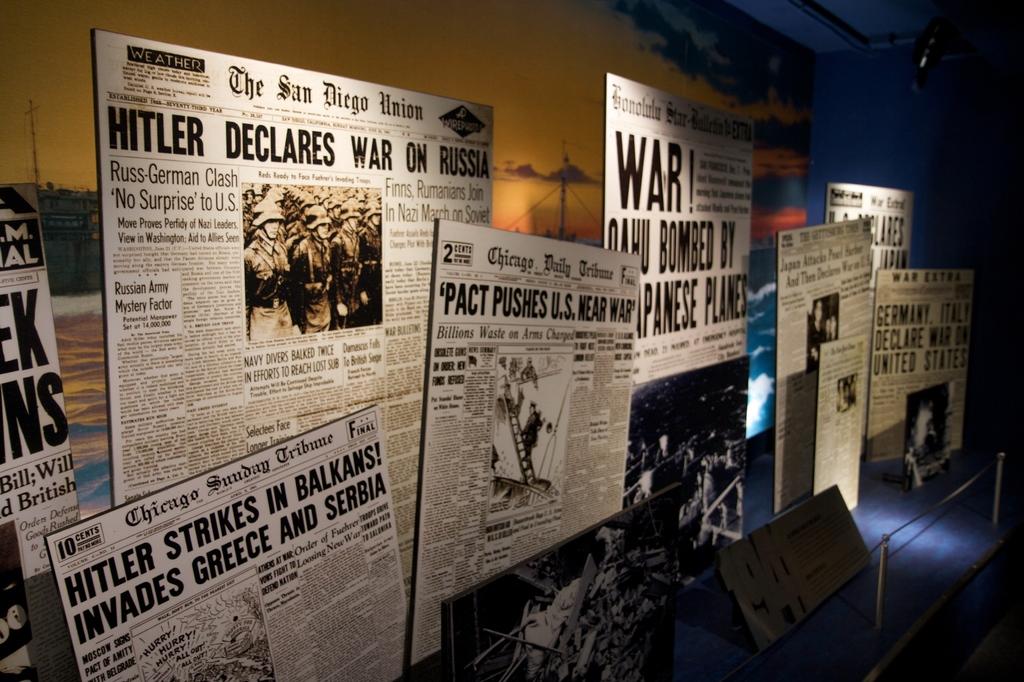What are the newspaper articles for?
Provide a short and direct response. Hitler. 